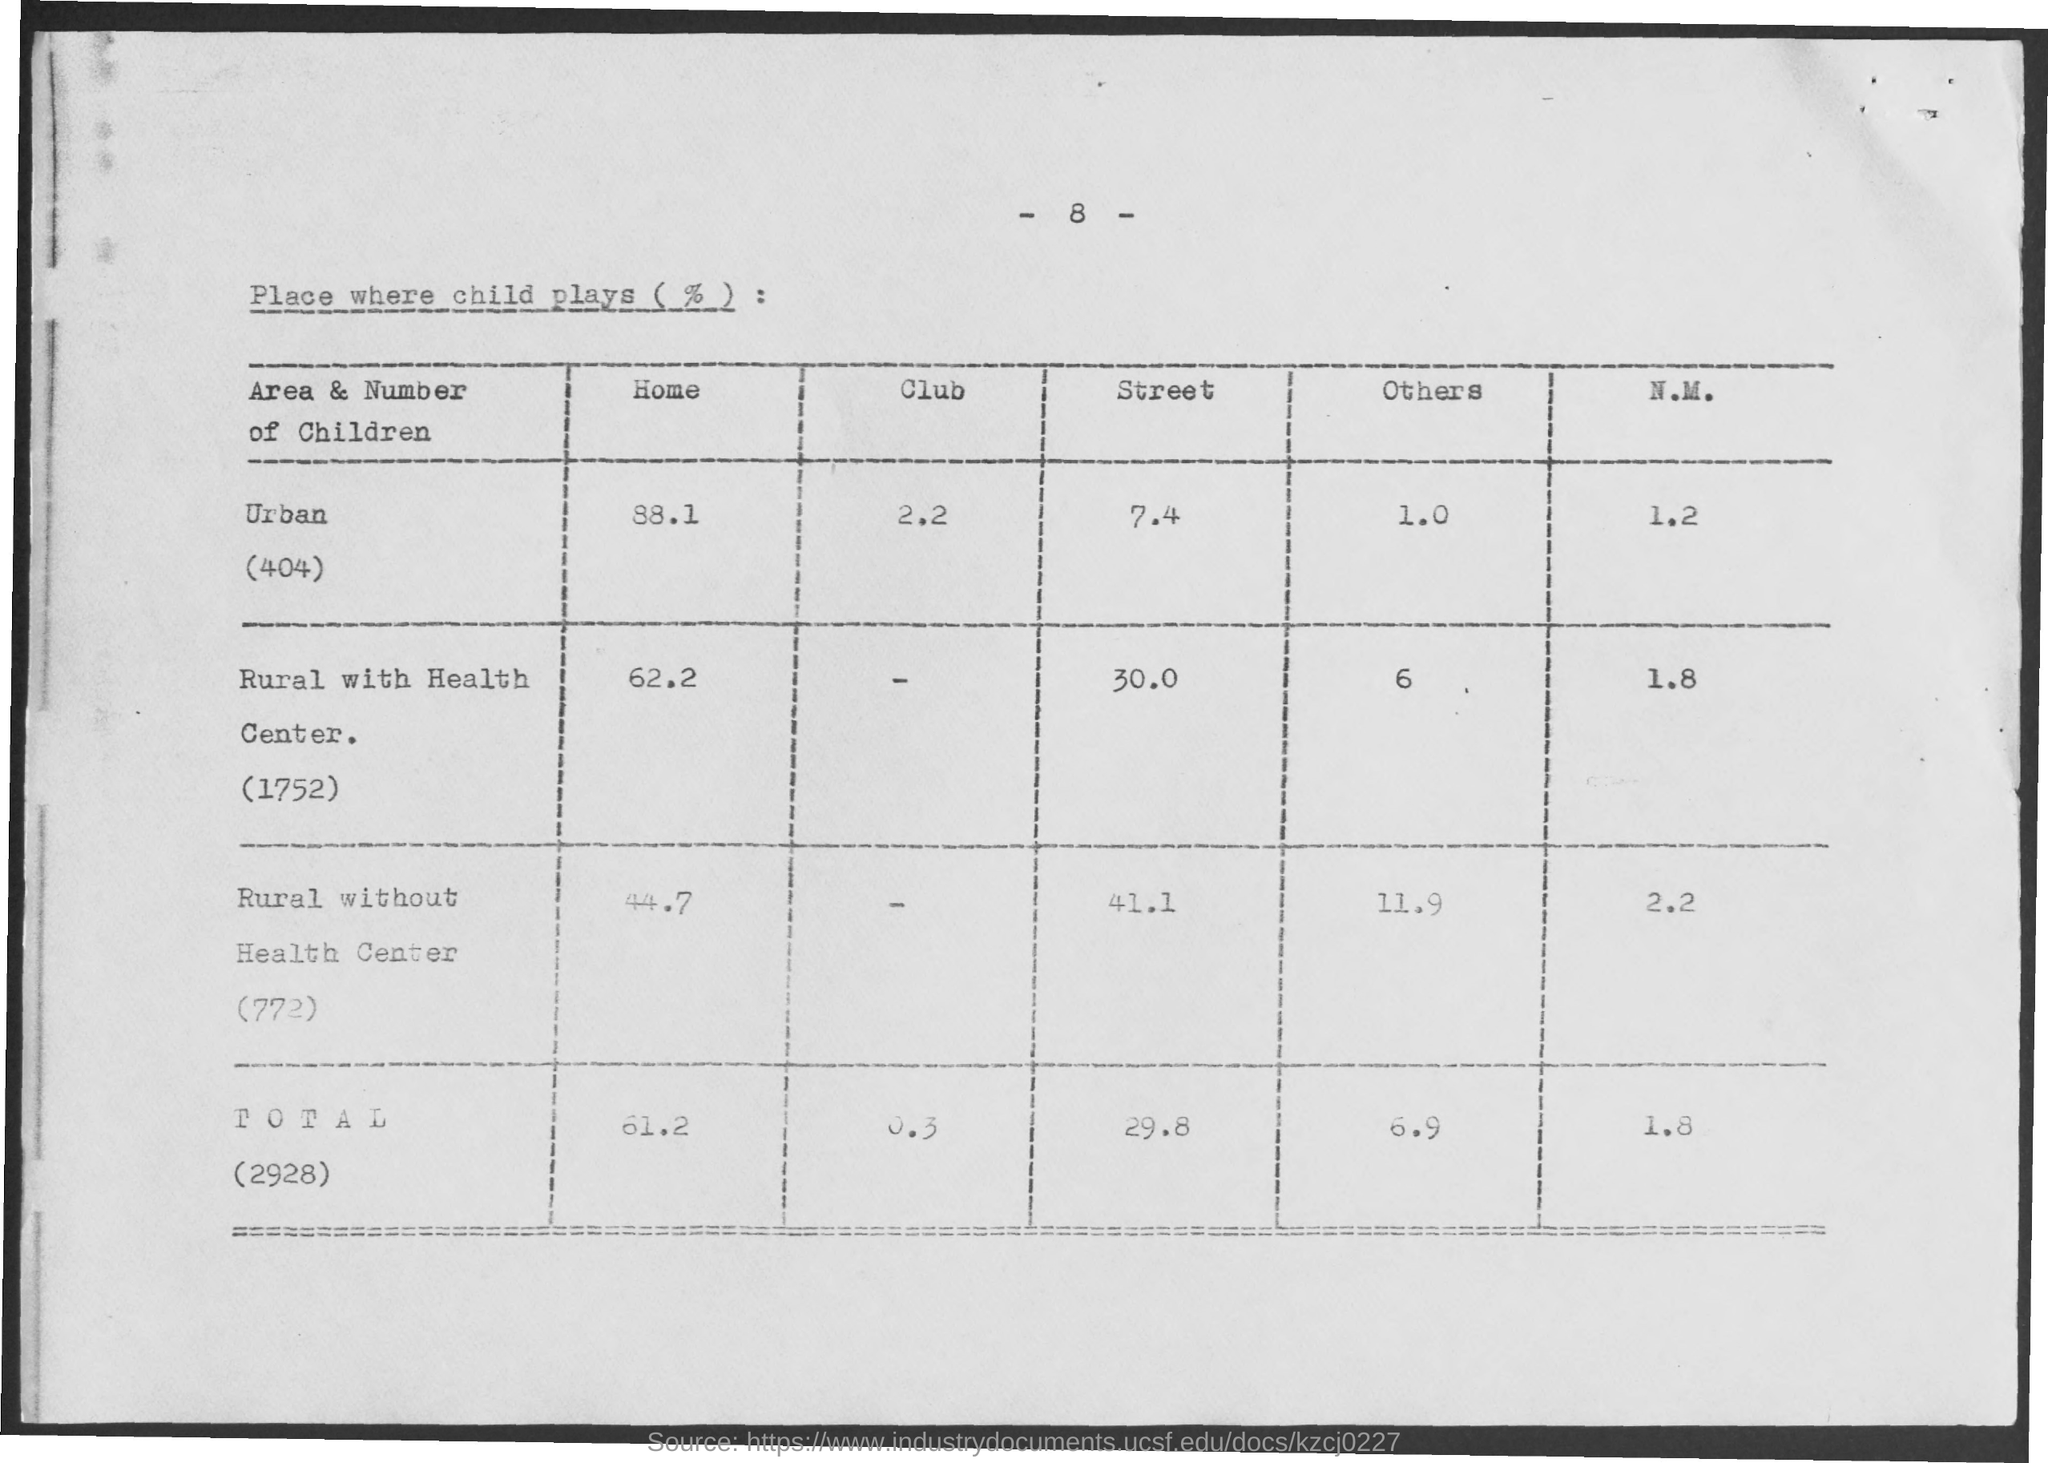List a handful of essential elements in this visual. In urban areas, approximately 88.1% of children play at home. In the rural area with a health center (ID 1752), approximately 30% of children play in the street. According to the data, in rural areas with a health center (1752), approximately 62.2% of children play at home. According to the data provided, approximately 1.8% of children in rural areas with a health center (1752) engage in playing New Mexico. According to data, a majority of children in rural areas with a health center (1752) engage in other activities besides sports. 